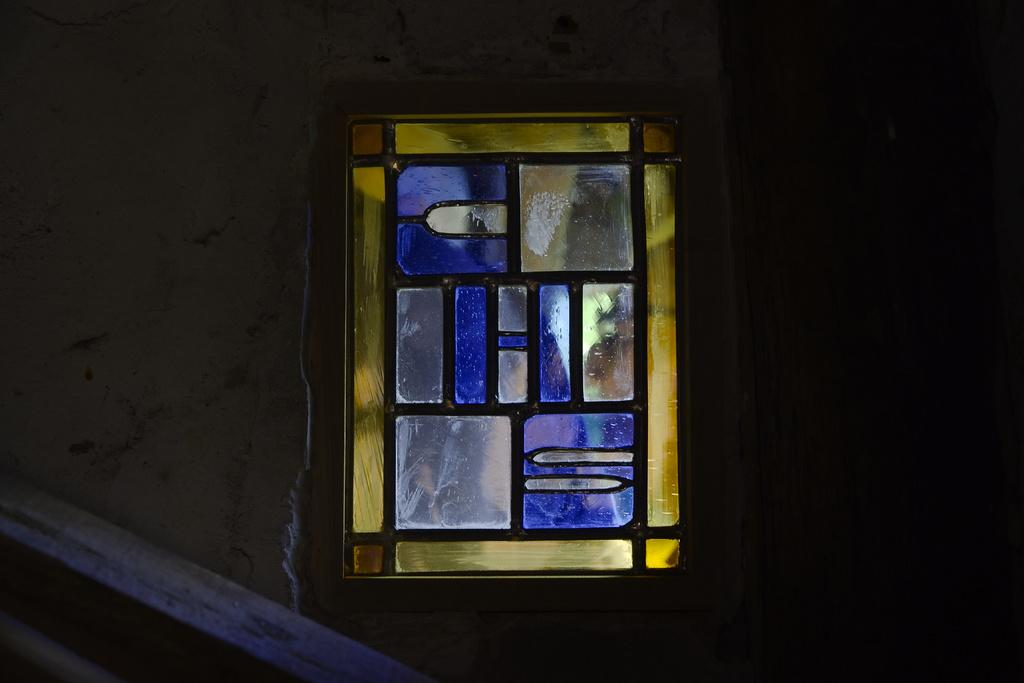What is present on the left side of the image? There is a wall on the left side of the image. What can be seen in the middle of the image? There is a window with glass in the image. How would you describe the right side of the image? The right side of the image is dark. What type of hair can be seen on the giraffe in the image? There is no giraffe present in the image, and therefore no hair can be observed. 